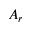Convert formula to latex. <formula><loc_0><loc_0><loc_500><loc_500>A _ { r }</formula> 